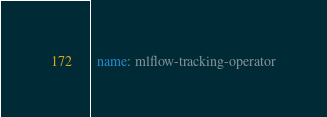<code> <loc_0><loc_0><loc_500><loc_500><_YAML_>  name: mlflow-tracking-operator
</code> 